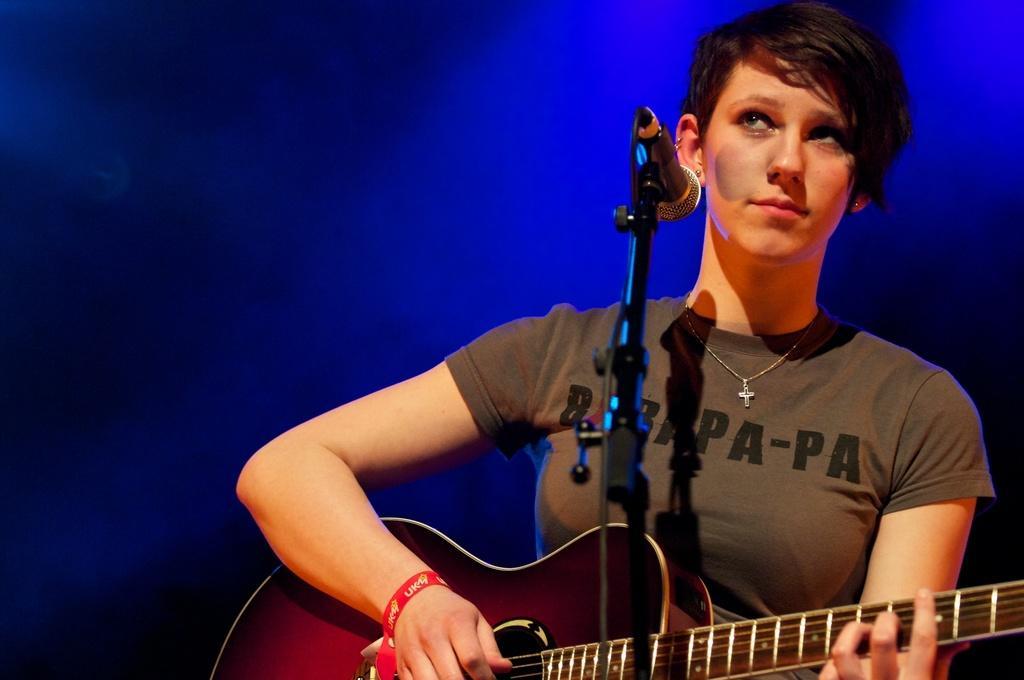Could you give a brief overview of what you see in this image? In this image I see a woman who is in front of a mic and she is holding the guitar. 